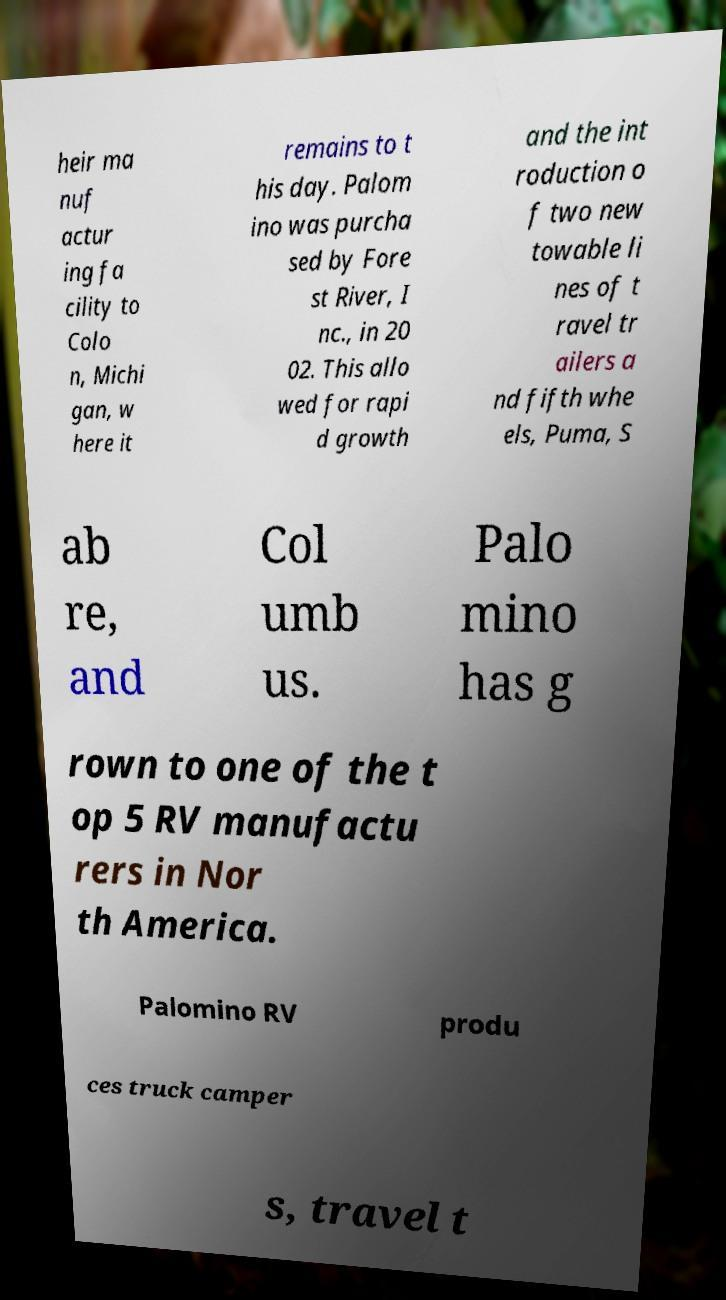Could you extract and type out the text from this image? heir ma nuf actur ing fa cility to Colo n, Michi gan, w here it remains to t his day. Palom ino was purcha sed by Fore st River, I nc., in 20 02. This allo wed for rapi d growth and the int roduction o f two new towable li nes of t ravel tr ailers a nd fifth whe els, Puma, S ab re, and Col umb us. Palo mino has g rown to one of the t op 5 RV manufactu rers in Nor th America. Palomino RV produ ces truck camper s, travel t 